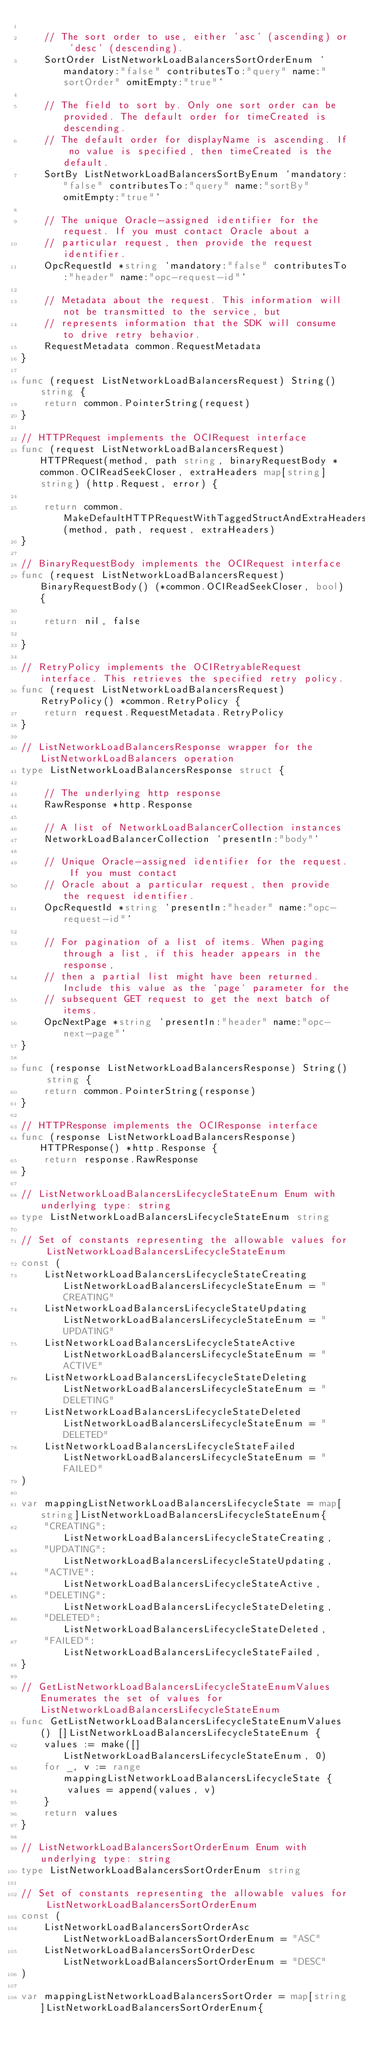<code> <loc_0><loc_0><loc_500><loc_500><_Go_>
	// The sort order to use, either 'asc' (ascending) or 'desc' (descending).
	SortOrder ListNetworkLoadBalancersSortOrderEnum `mandatory:"false" contributesTo:"query" name:"sortOrder" omitEmpty:"true"`

	// The field to sort by. Only one sort order can be provided. The default order for timeCreated is descending.
	// The default order for displayName is ascending. If no value is specified, then timeCreated is the default.
	SortBy ListNetworkLoadBalancersSortByEnum `mandatory:"false" contributesTo:"query" name:"sortBy" omitEmpty:"true"`

	// The unique Oracle-assigned identifier for the request. If you must contact Oracle about a
	// particular request, then provide the request identifier.
	OpcRequestId *string `mandatory:"false" contributesTo:"header" name:"opc-request-id"`

	// Metadata about the request. This information will not be transmitted to the service, but
	// represents information that the SDK will consume to drive retry behavior.
	RequestMetadata common.RequestMetadata
}

func (request ListNetworkLoadBalancersRequest) String() string {
	return common.PointerString(request)
}

// HTTPRequest implements the OCIRequest interface
func (request ListNetworkLoadBalancersRequest) HTTPRequest(method, path string, binaryRequestBody *common.OCIReadSeekCloser, extraHeaders map[string]string) (http.Request, error) {

	return common.MakeDefaultHTTPRequestWithTaggedStructAndExtraHeaders(method, path, request, extraHeaders)
}

// BinaryRequestBody implements the OCIRequest interface
func (request ListNetworkLoadBalancersRequest) BinaryRequestBody() (*common.OCIReadSeekCloser, bool) {

	return nil, false

}

// RetryPolicy implements the OCIRetryableRequest interface. This retrieves the specified retry policy.
func (request ListNetworkLoadBalancersRequest) RetryPolicy() *common.RetryPolicy {
	return request.RequestMetadata.RetryPolicy
}

// ListNetworkLoadBalancersResponse wrapper for the ListNetworkLoadBalancers operation
type ListNetworkLoadBalancersResponse struct {

	// The underlying http response
	RawResponse *http.Response

	// A list of NetworkLoadBalancerCollection instances
	NetworkLoadBalancerCollection `presentIn:"body"`

	// Unique Oracle-assigned identifier for the request. If you must contact
	// Oracle about a particular request, then provide the request identifier.
	OpcRequestId *string `presentIn:"header" name:"opc-request-id"`

	// For pagination of a list of items. When paging through a list, if this header appears in the response,
	// then a partial list might have been returned. Include this value as the `page` parameter for the
	// subsequent GET request to get the next batch of items.
	OpcNextPage *string `presentIn:"header" name:"opc-next-page"`
}

func (response ListNetworkLoadBalancersResponse) String() string {
	return common.PointerString(response)
}

// HTTPResponse implements the OCIResponse interface
func (response ListNetworkLoadBalancersResponse) HTTPResponse() *http.Response {
	return response.RawResponse
}

// ListNetworkLoadBalancersLifecycleStateEnum Enum with underlying type: string
type ListNetworkLoadBalancersLifecycleStateEnum string

// Set of constants representing the allowable values for ListNetworkLoadBalancersLifecycleStateEnum
const (
	ListNetworkLoadBalancersLifecycleStateCreating ListNetworkLoadBalancersLifecycleStateEnum = "CREATING"
	ListNetworkLoadBalancersLifecycleStateUpdating ListNetworkLoadBalancersLifecycleStateEnum = "UPDATING"
	ListNetworkLoadBalancersLifecycleStateActive   ListNetworkLoadBalancersLifecycleStateEnum = "ACTIVE"
	ListNetworkLoadBalancersLifecycleStateDeleting ListNetworkLoadBalancersLifecycleStateEnum = "DELETING"
	ListNetworkLoadBalancersLifecycleStateDeleted  ListNetworkLoadBalancersLifecycleStateEnum = "DELETED"
	ListNetworkLoadBalancersLifecycleStateFailed   ListNetworkLoadBalancersLifecycleStateEnum = "FAILED"
)

var mappingListNetworkLoadBalancersLifecycleState = map[string]ListNetworkLoadBalancersLifecycleStateEnum{
	"CREATING": ListNetworkLoadBalancersLifecycleStateCreating,
	"UPDATING": ListNetworkLoadBalancersLifecycleStateUpdating,
	"ACTIVE":   ListNetworkLoadBalancersLifecycleStateActive,
	"DELETING": ListNetworkLoadBalancersLifecycleStateDeleting,
	"DELETED":  ListNetworkLoadBalancersLifecycleStateDeleted,
	"FAILED":   ListNetworkLoadBalancersLifecycleStateFailed,
}

// GetListNetworkLoadBalancersLifecycleStateEnumValues Enumerates the set of values for ListNetworkLoadBalancersLifecycleStateEnum
func GetListNetworkLoadBalancersLifecycleStateEnumValues() []ListNetworkLoadBalancersLifecycleStateEnum {
	values := make([]ListNetworkLoadBalancersLifecycleStateEnum, 0)
	for _, v := range mappingListNetworkLoadBalancersLifecycleState {
		values = append(values, v)
	}
	return values
}

// ListNetworkLoadBalancersSortOrderEnum Enum with underlying type: string
type ListNetworkLoadBalancersSortOrderEnum string

// Set of constants representing the allowable values for ListNetworkLoadBalancersSortOrderEnum
const (
	ListNetworkLoadBalancersSortOrderAsc  ListNetworkLoadBalancersSortOrderEnum = "ASC"
	ListNetworkLoadBalancersSortOrderDesc ListNetworkLoadBalancersSortOrderEnum = "DESC"
)

var mappingListNetworkLoadBalancersSortOrder = map[string]ListNetworkLoadBalancersSortOrderEnum{</code> 